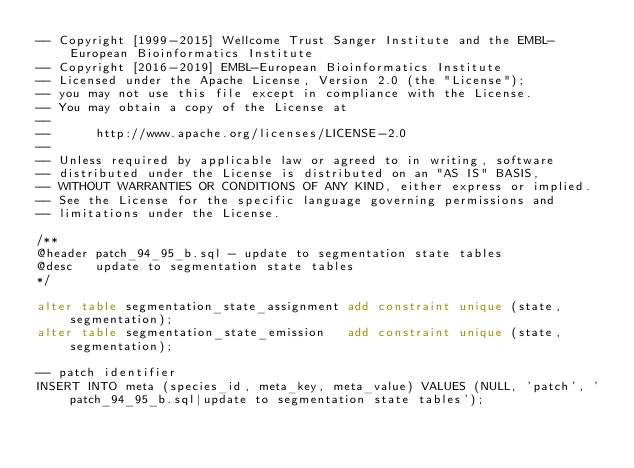<code> <loc_0><loc_0><loc_500><loc_500><_SQL_>-- Copyright [1999-2015] Wellcome Trust Sanger Institute and the EMBL-European Bioinformatics Institute
-- Copyright [2016-2019] EMBL-European Bioinformatics Institute
-- Licensed under the Apache License, Version 2.0 (the "License");
-- you may not use this file except in compliance with the License.
-- You may obtain a copy of the License at
--
--      http://www.apache.org/licenses/LICENSE-2.0
--
-- Unless required by applicable law or agreed to in writing, software
-- distributed under the License is distributed on an "AS IS" BASIS,
-- WITHOUT WARRANTIES OR CONDITIONS OF ANY KIND, either express or implied.
-- See the License for the specific language governing permissions and
-- limitations under the License.

/**
@header patch_94_95_b.sql - update to segmentation state tables
@desc   update to segmentation state tables
*/

alter table segmentation_state_assignment add constraint unique (state, segmentation);
alter table segmentation_state_emission   add constraint unique (state, segmentation);

-- patch identifier
INSERT INTO meta (species_id, meta_key, meta_value) VALUES (NULL, 'patch', 'patch_94_95_b.sql|update to segmentation state tables');
</code> 